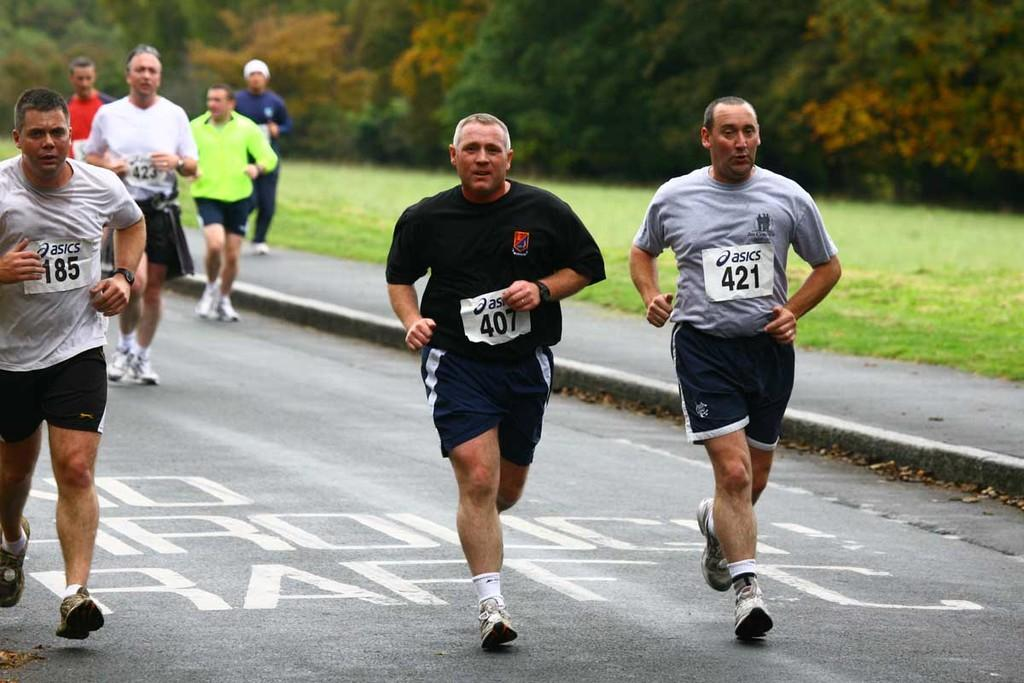What is the setting of the image? The image is an outside view. Who is present in the image? There are men in the image. What are the men wearing? The men are wearing t-shirts and shorts. What are the men doing in the image? The men are running on the road. What can be seen in the background of the image? There is grass on the ground and many trees in the background. What type of liquid can be seen flowing through the trees in the image? There is no liquid visible in the image; it features men running on the road with trees and grass in the background. How many knots are tied in the branches of the trees in the image? There are no knots present in the image, as it depicts trees in their natural state. 